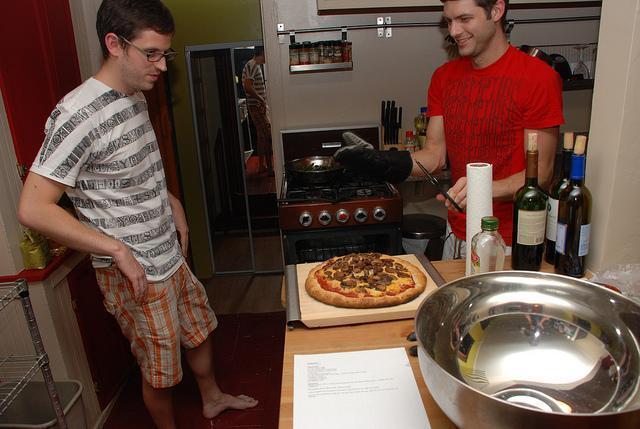How many bottles of wine are to the right in front to the man who is cutting the pizza?
Pick the right solution, then justify: 'Answer: answer
Rationale: rationale.'
Options: One, three, two, four. Answer: three.
Rationale: There are 3. 